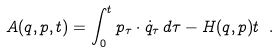Convert formula to latex. <formula><loc_0><loc_0><loc_500><loc_500>A ( q , p , t ) = \int _ { 0 } ^ { t } p _ { \tau } \cdot \dot { q } _ { \tau } \, d \tau - H ( q , p ) t \ .</formula> 